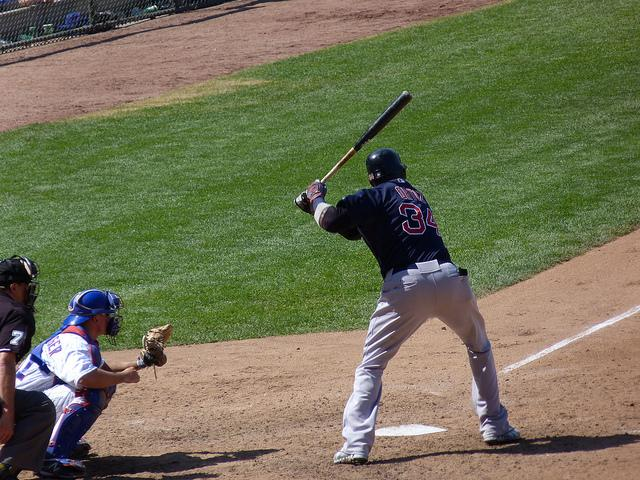What is the nickname of this player?

Choices:
A) closer
B) el hombre
C) big papi
D) slugger big papi 